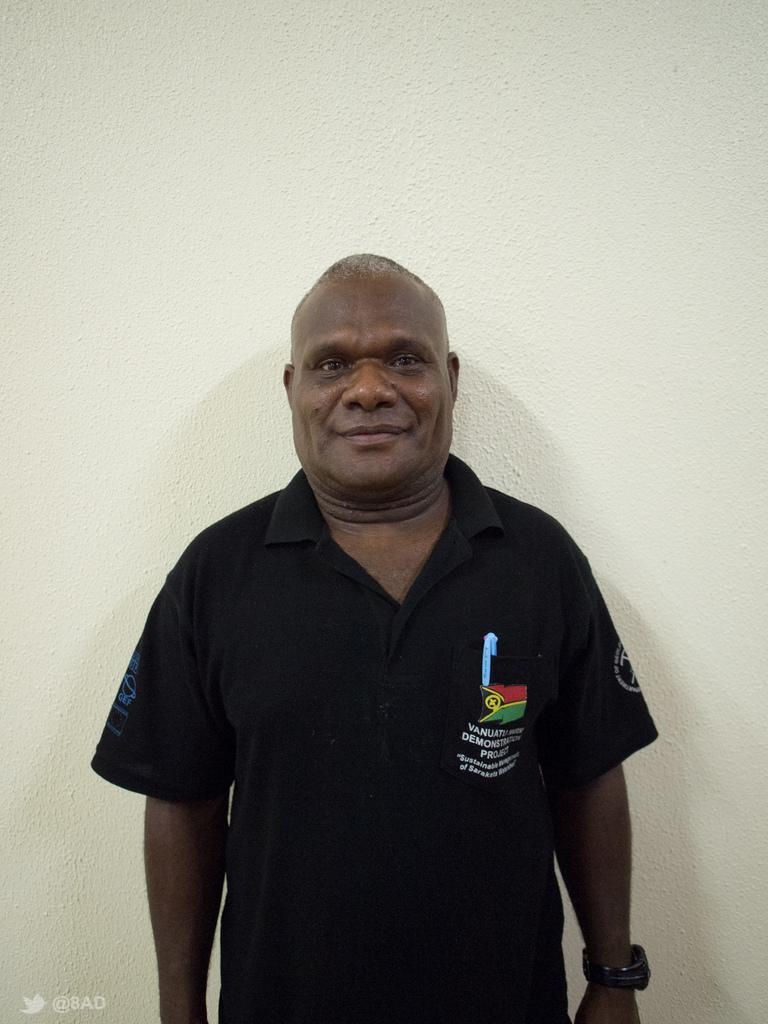What is the main subject of the image? There is a person standing in the image. What is the person wearing? The person is wearing a black dress. What color is the background of the image? The background of the image is white. Can you see a man performing on a stage in the image? There is no man performing on a stage in the image; it only features a person standing in a white background. How many hens are visible in the image? There are no hens present in the image. 